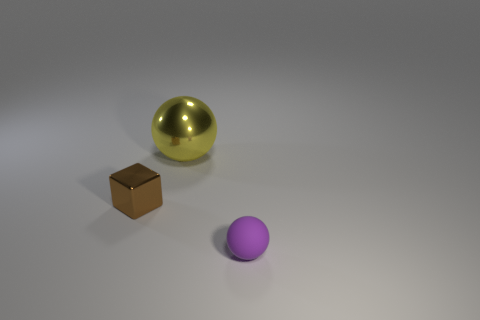How many other objects are the same size as the purple rubber thing?
Provide a short and direct response. 1. How many small objects are both to the right of the brown block and behind the small rubber sphere?
Ensure brevity in your answer.  0. Do the sphere in front of the brown metal block and the object to the left of the big yellow metallic thing have the same size?
Offer a terse response. Yes. What size is the sphere that is behind the small purple rubber sphere?
Your answer should be very brief. Large. How many objects are tiny things that are in front of the brown object or objects that are left of the yellow shiny ball?
Keep it short and to the point. 2. Is there anything else that is the same color as the small matte thing?
Provide a succinct answer. No. Is the number of small metal blocks that are in front of the purple sphere the same as the number of brown things in front of the yellow metallic sphere?
Provide a short and direct response. No. Is the number of metal spheres in front of the tiny purple thing greater than the number of big yellow spheres?
Give a very brief answer. No. What number of objects are either tiny objects that are behind the purple matte object or small things?
Your answer should be very brief. 2. How many big things have the same material as the small purple thing?
Offer a terse response. 0. 